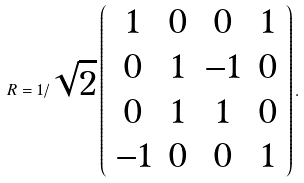Convert formula to latex. <formula><loc_0><loc_0><loc_500><loc_500>R = 1 / \sqrt { 2 } \left ( \begin{array} { c c c c } 1 & 0 & 0 & 1 \\ 0 & 1 & - 1 & 0 \\ 0 & 1 & 1 & 0 \\ - 1 & 0 & 0 & 1 \\ \end{array} \right ) .</formula> 